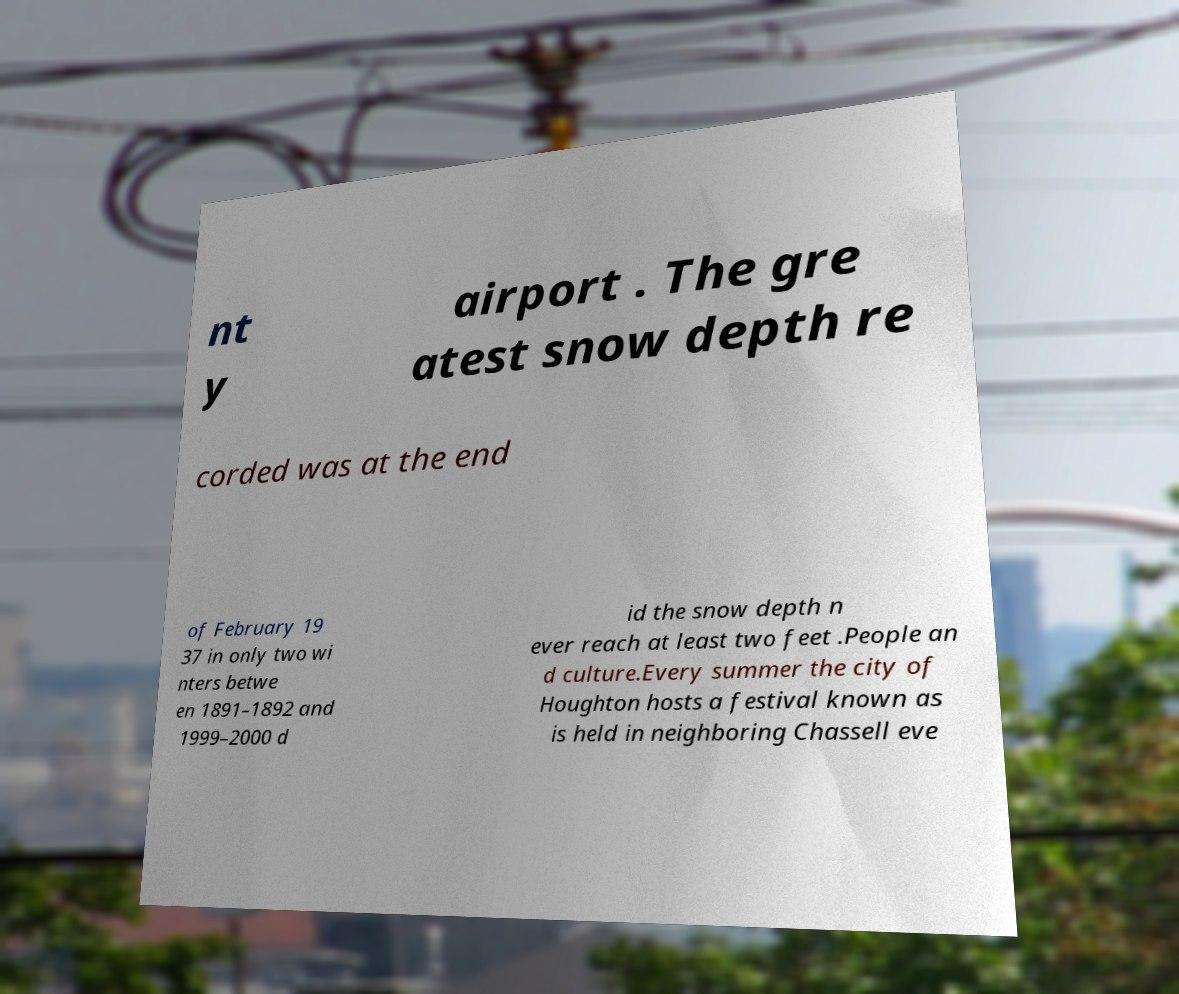What messages or text are displayed in this image? I need them in a readable, typed format. nt y airport . The gre atest snow depth re corded was at the end of February 19 37 in only two wi nters betwe en 1891–1892 and 1999–2000 d id the snow depth n ever reach at least two feet .People an d culture.Every summer the city of Houghton hosts a festival known as is held in neighboring Chassell eve 